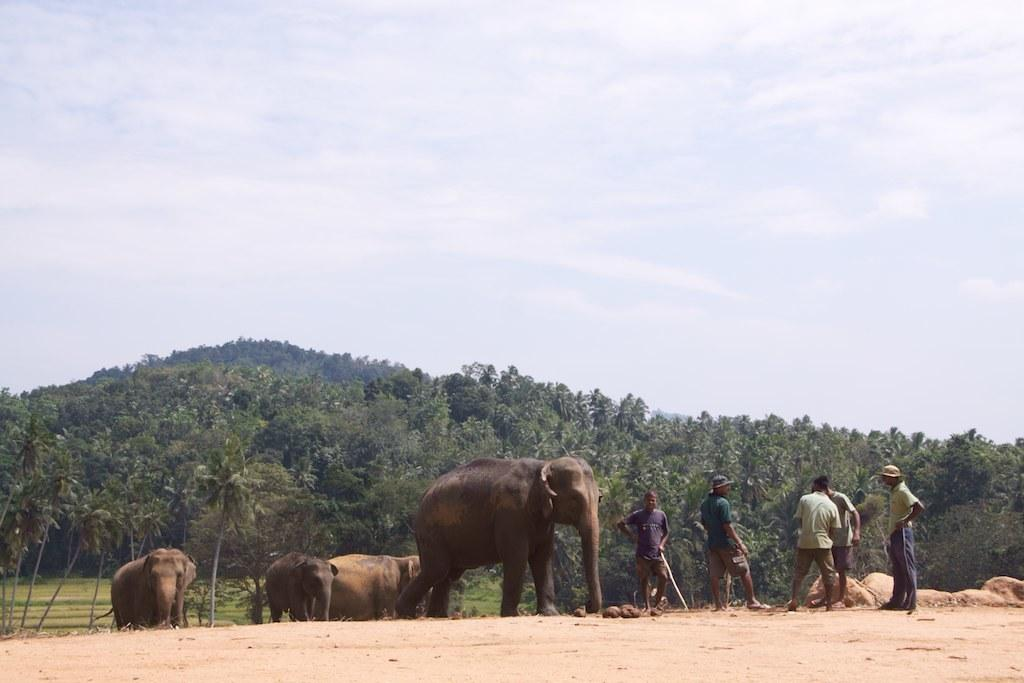How many elephants are present in the image? There are four elephants in the image. What is located at the bottom of the image? There is ground at the bottom of the image. Can you describe the people in the image? There are five men standing on the right side of the image. What can be seen in the background of the image? There are trees in the background of the image. What is visible at the top of the image? The sky is visible at the top of the image. What type of mist can be seen surrounding the elephants in the image? There is no mist present in the image; the elephants are not surrounded by any mist. 